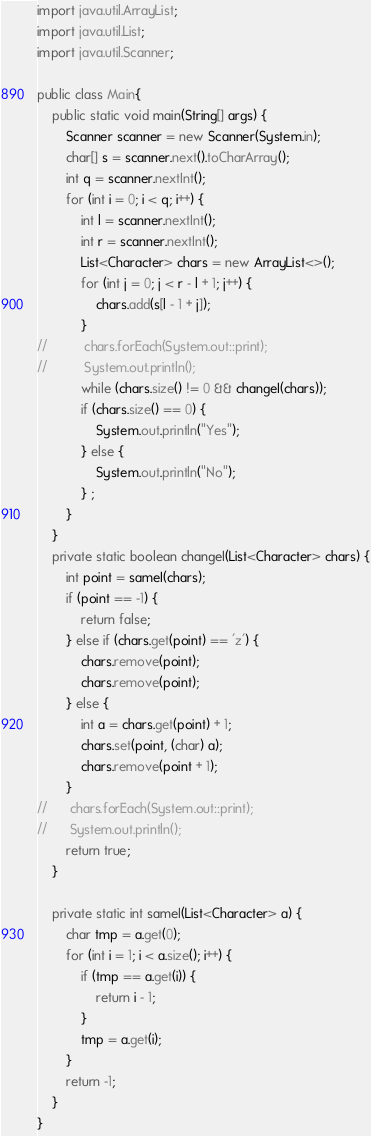Convert code to text. <code><loc_0><loc_0><loc_500><loc_500><_Java_>import java.util.ArrayList;
import java.util.List;
import java.util.Scanner;

public class Main{
	public static void main(String[] args) {
		Scanner scanner = new Scanner(System.in);
		char[] s = scanner.next().toCharArray();
		int q = scanner.nextInt();
		for (int i = 0; i < q; i++) {
			int l = scanner.nextInt();
			int r = scanner.nextInt();
			List<Character> chars = new ArrayList<>();
			for (int j = 0; j < r - l + 1; j++) {
				chars.add(s[l - 1 + j]);
			}
//			chars.forEach(System.out::print);
//			System.out.println();
			while (chars.size() != 0 && changeI(chars));
			if (chars.size() == 0) {
				System.out.println("Yes");
			} else {
				System.out.println("No");
			} ;
		}
	}
	private static boolean changeI(List<Character> chars) {
		int point = sameI(chars);
		if (point == -1) {
			return false;
		} else if (chars.get(point) == 'z') {
			chars.remove(point);
			chars.remove(point);
		} else {
			int a = chars.get(point) + 1;
			chars.set(point, (char) a);
			chars.remove(point + 1);
		}
//		chars.forEach(System.out::print);
//		System.out.println();
		return true;
	}

	private static int sameI(List<Character> a) {
		char tmp = a.get(0);
		for (int i = 1; i < a.size(); i++) {
			if (tmp == a.get(i)) {
				return i - 1;
			}
			tmp = a.get(i);
		}
		return -1;
	}
}
</code> 